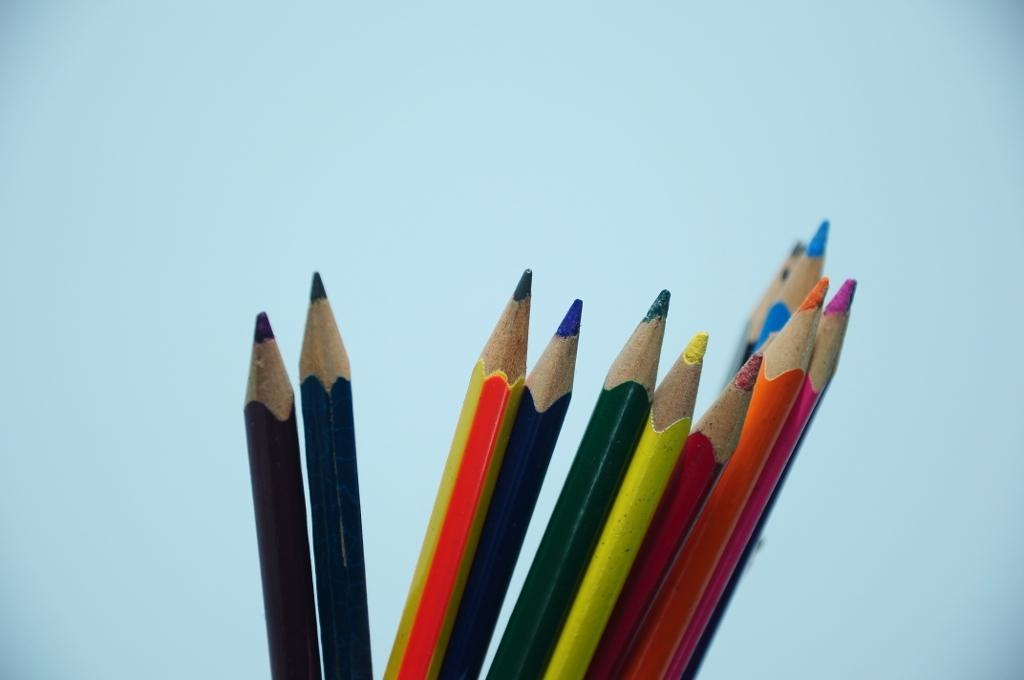What types of writing instruments are visible in the image? There are different colors of pencils in the image. What color is the background of the image? The background of the image is light blue. How many toads can be seen sitting on the pencils in the image? There are no toads present in the image; it features pencils and a light blue background. What type of fruit is placed on top of the pencils in the image? There is no fruit, such as a cherry, present on top of the pencils in the image. 